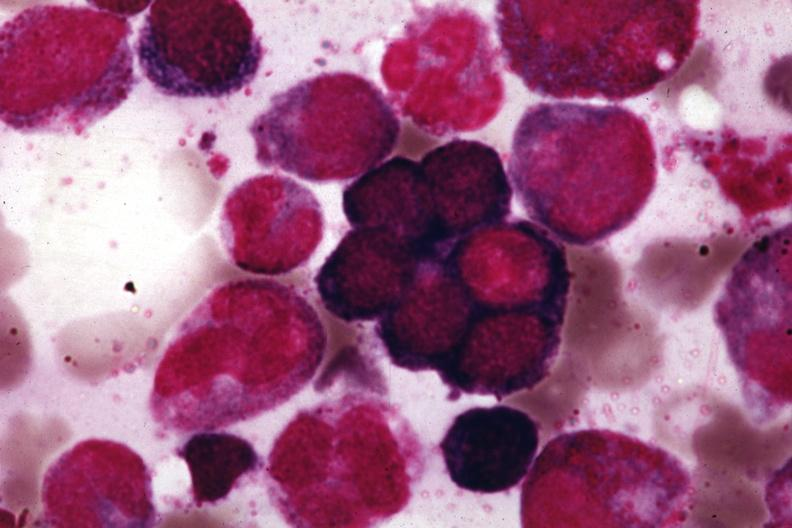what is present?
Answer the question using a single word or phrase. Megaloblasts pernicious anemia 